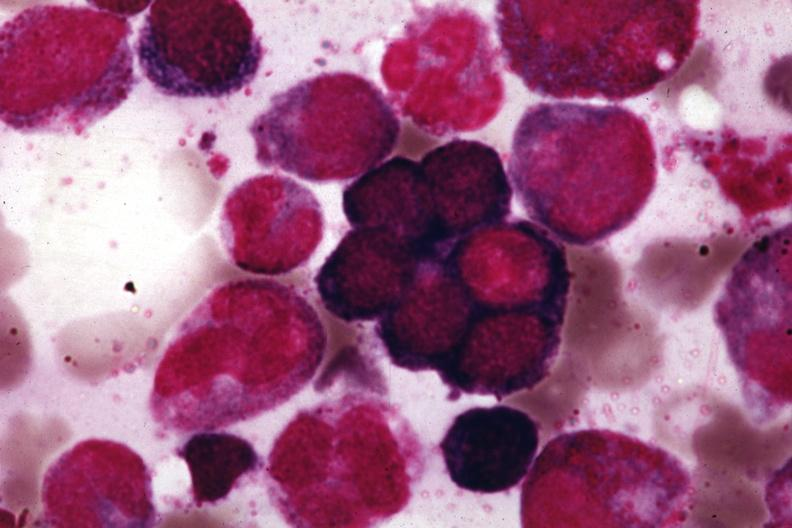what is present?
Answer the question using a single word or phrase. Megaloblasts pernicious anemia 